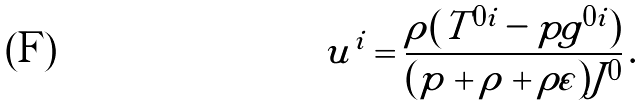<formula> <loc_0><loc_0><loc_500><loc_500>u ^ { i } = \frac { \rho ( T ^ { 0 i } - p g ^ { 0 i } ) } { ( p + \rho + \rho \varepsilon ) J ^ { 0 } } \, .</formula> 